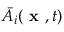<formula> <loc_0><loc_0><loc_500><loc_500>\bar { A } _ { i } { ( x , t ) }</formula> 